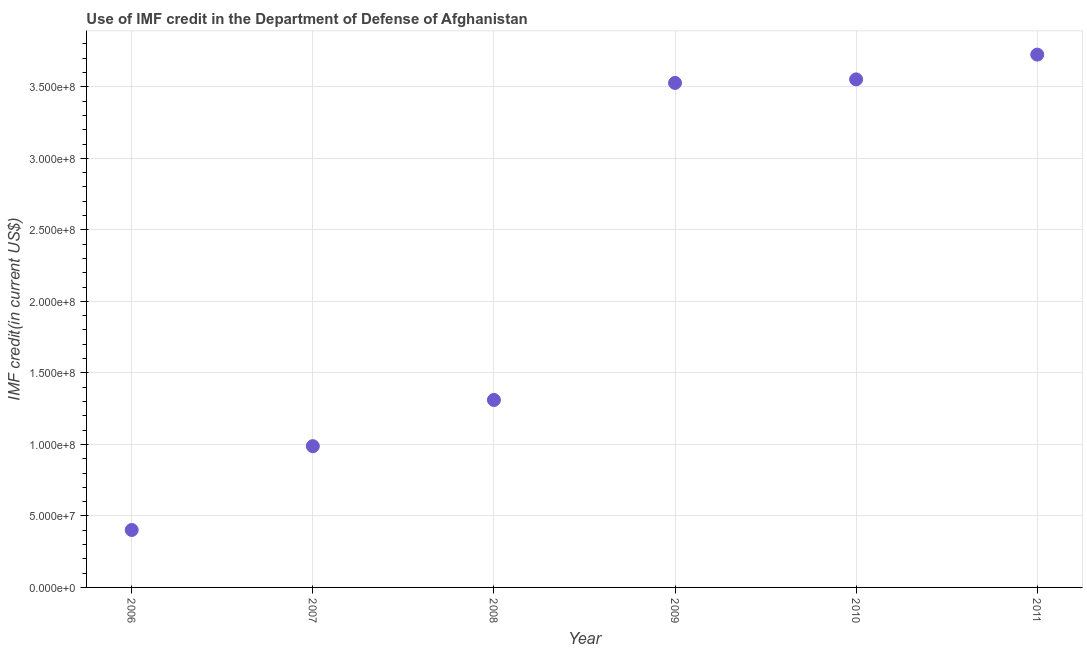What is the use of imf credit in dod in 2008?
Your response must be concise. 1.31e+08. Across all years, what is the maximum use of imf credit in dod?
Provide a succinct answer. 3.73e+08. Across all years, what is the minimum use of imf credit in dod?
Your response must be concise. 4.02e+07. In which year was the use of imf credit in dod maximum?
Offer a terse response. 2011. What is the sum of the use of imf credit in dod?
Your answer should be very brief. 1.35e+09. What is the difference between the use of imf credit in dod in 2006 and 2011?
Your response must be concise. -3.32e+08. What is the average use of imf credit in dod per year?
Make the answer very short. 2.25e+08. What is the median use of imf credit in dod?
Keep it short and to the point. 2.42e+08. Do a majority of the years between 2011 and 2010 (inclusive) have use of imf credit in dod greater than 150000000 US$?
Your answer should be compact. No. What is the ratio of the use of imf credit in dod in 2009 to that in 2011?
Keep it short and to the point. 0.95. Is the use of imf credit in dod in 2009 less than that in 2011?
Offer a terse response. Yes. What is the difference between the highest and the second highest use of imf credit in dod?
Your response must be concise. 1.73e+07. Is the sum of the use of imf credit in dod in 2006 and 2011 greater than the maximum use of imf credit in dod across all years?
Offer a very short reply. Yes. What is the difference between the highest and the lowest use of imf credit in dod?
Make the answer very short. 3.32e+08. In how many years, is the use of imf credit in dod greater than the average use of imf credit in dod taken over all years?
Your response must be concise. 3. How many years are there in the graph?
Offer a very short reply. 6. What is the difference between two consecutive major ticks on the Y-axis?
Your response must be concise. 5.00e+07. What is the title of the graph?
Your response must be concise. Use of IMF credit in the Department of Defense of Afghanistan. What is the label or title of the X-axis?
Your response must be concise. Year. What is the label or title of the Y-axis?
Offer a terse response. IMF credit(in current US$). What is the IMF credit(in current US$) in 2006?
Provide a succinct answer. 4.02e+07. What is the IMF credit(in current US$) in 2007?
Provide a short and direct response. 9.88e+07. What is the IMF credit(in current US$) in 2008?
Offer a very short reply. 1.31e+08. What is the IMF credit(in current US$) in 2009?
Provide a short and direct response. 3.53e+08. What is the IMF credit(in current US$) in 2010?
Make the answer very short. 3.55e+08. What is the IMF credit(in current US$) in 2011?
Your answer should be compact. 3.73e+08. What is the difference between the IMF credit(in current US$) in 2006 and 2007?
Your response must be concise. -5.86e+07. What is the difference between the IMF credit(in current US$) in 2006 and 2008?
Offer a terse response. -9.09e+07. What is the difference between the IMF credit(in current US$) in 2006 and 2009?
Offer a very short reply. -3.13e+08. What is the difference between the IMF credit(in current US$) in 2006 and 2010?
Provide a short and direct response. -3.15e+08. What is the difference between the IMF credit(in current US$) in 2006 and 2011?
Offer a terse response. -3.32e+08. What is the difference between the IMF credit(in current US$) in 2007 and 2008?
Ensure brevity in your answer.  -3.23e+07. What is the difference between the IMF credit(in current US$) in 2007 and 2009?
Your response must be concise. -2.54e+08. What is the difference between the IMF credit(in current US$) in 2007 and 2010?
Provide a succinct answer. -2.56e+08. What is the difference between the IMF credit(in current US$) in 2007 and 2011?
Your answer should be very brief. -2.74e+08. What is the difference between the IMF credit(in current US$) in 2008 and 2009?
Your answer should be compact. -2.22e+08. What is the difference between the IMF credit(in current US$) in 2008 and 2010?
Your answer should be very brief. -2.24e+08. What is the difference between the IMF credit(in current US$) in 2008 and 2011?
Keep it short and to the point. -2.41e+08. What is the difference between the IMF credit(in current US$) in 2009 and 2010?
Make the answer very short. -2.48e+06. What is the difference between the IMF credit(in current US$) in 2009 and 2011?
Give a very brief answer. -1.98e+07. What is the difference between the IMF credit(in current US$) in 2010 and 2011?
Make the answer very short. -1.73e+07. What is the ratio of the IMF credit(in current US$) in 2006 to that in 2007?
Give a very brief answer. 0.41. What is the ratio of the IMF credit(in current US$) in 2006 to that in 2008?
Offer a very short reply. 0.31. What is the ratio of the IMF credit(in current US$) in 2006 to that in 2009?
Ensure brevity in your answer.  0.11. What is the ratio of the IMF credit(in current US$) in 2006 to that in 2010?
Offer a very short reply. 0.11. What is the ratio of the IMF credit(in current US$) in 2006 to that in 2011?
Ensure brevity in your answer.  0.11. What is the ratio of the IMF credit(in current US$) in 2007 to that in 2008?
Your response must be concise. 0.75. What is the ratio of the IMF credit(in current US$) in 2007 to that in 2009?
Keep it short and to the point. 0.28. What is the ratio of the IMF credit(in current US$) in 2007 to that in 2010?
Provide a succinct answer. 0.28. What is the ratio of the IMF credit(in current US$) in 2007 to that in 2011?
Offer a terse response. 0.27. What is the ratio of the IMF credit(in current US$) in 2008 to that in 2009?
Make the answer very short. 0.37. What is the ratio of the IMF credit(in current US$) in 2008 to that in 2010?
Keep it short and to the point. 0.37. What is the ratio of the IMF credit(in current US$) in 2008 to that in 2011?
Make the answer very short. 0.35. What is the ratio of the IMF credit(in current US$) in 2009 to that in 2011?
Provide a short and direct response. 0.95. What is the ratio of the IMF credit(in current US$) in 2010 to that in 2011?
Keep it short and to the point. 0.95. 